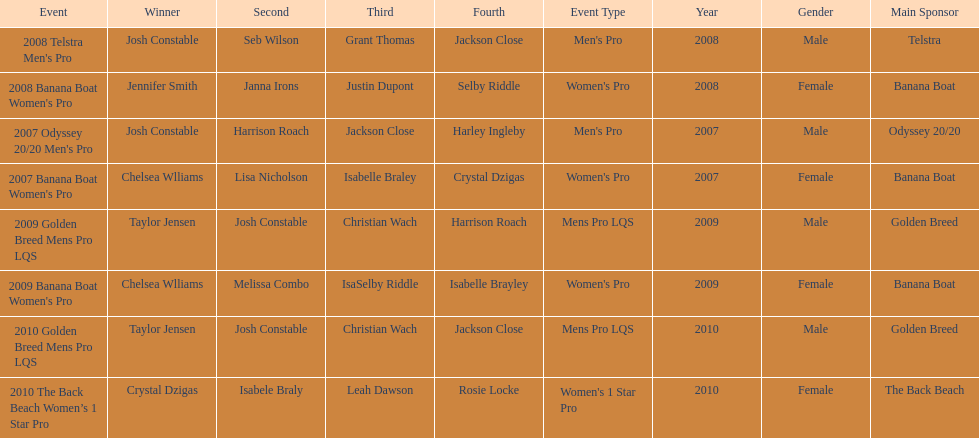From 2007 to 2010, what is the count of chelsea williams' winning instances? 2. 